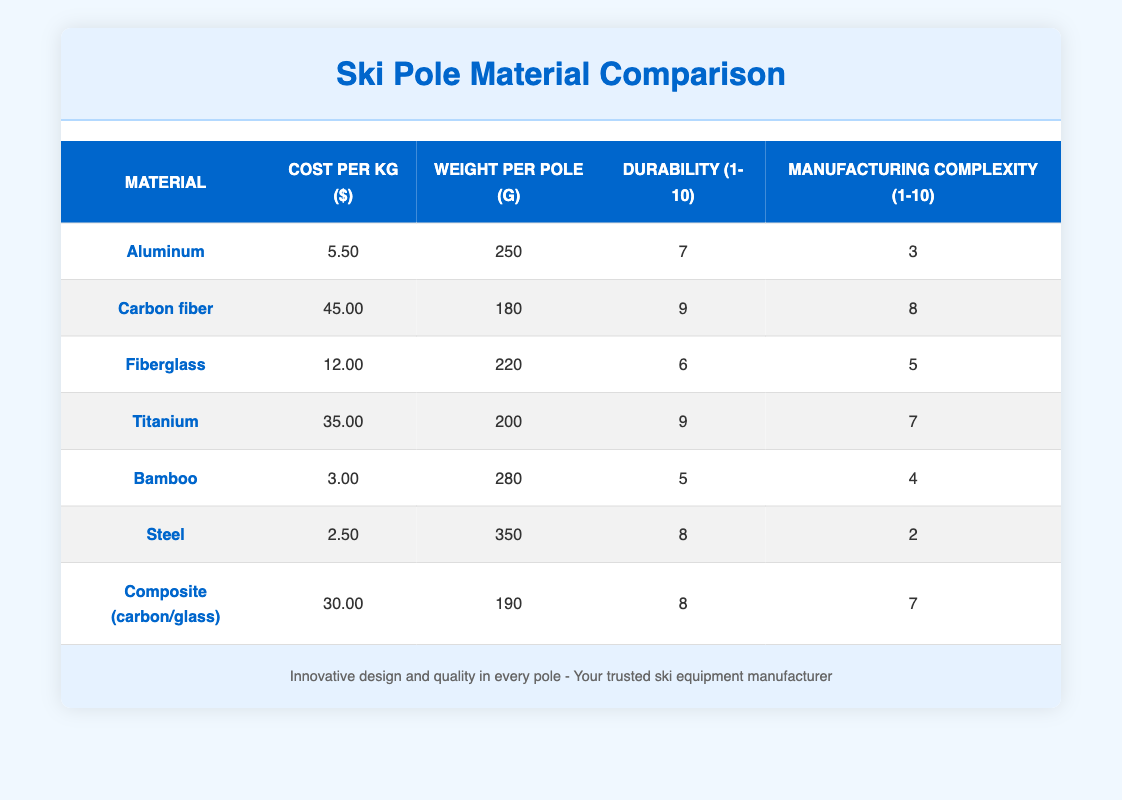What is the cost per kg of carbon fiber? The table states that the cost per kg of carbon fiber is listed directly under the "Cost per kg ($)" column in the corresponding row for carbon fiber. This value is 45.00.
Answer: 45.00 Which material has the highest durability rating? By looking at the "Durability (1-10)" column, the highest value present is 9, which appears in the rows for carbon fiber and titanium. Thus, these two materials have the highest durability rating.
Answer: Carbon fiber and titanium What is the average weight per pole of aluminum and fiberglass? The weight of aluminum is 250 g and fiberglass is 220 g. To find the average, we add the two weights: 250 + 220 = 470 g, then divide by 2 to get the average: 470 / 2 = 235 g.
Answer: 235 g Is bamboo more expensive than steel per kg? The cost per kg of bamboo is 3.00 and that of steel is 2.50. Since 3.00 is greater than 2.50, bamboo is indeed more expensive than steel.
Answer: Yes Which material has the lowest manufacturing complexity? From the "Manufacturing complexity (1-10)" column, the lowest value is 2, which corresponds to steel. Hence, steel has the lowest complexity in manufacturing among the listed materials.
Answer: Steel What is the total cost per kg of using composite (carbon/glass) and aluminum? The cost per kg of composite (carbon/glass) is 30.00 and aluminum is 5.50. To find the total cost, we add these values: 30.00 + 5.50 = 35.50.
Answer: 35.50 Which materials have a weight of less than 250 grams per pole? The materials with a weight less than 250 grams are carbon fiber (180 g), titanium (200 g), and bamboo (280 g, which does not qualify). Filtering the rows, we see only carbon fiber and titanium meet this criterion.
Answer: Carbon fiber and titanium What is the difference in durability between the strongest and the weakest material? The strongest material, carbon fiber and titanium, has a durability rating of 9, and the weakest, bamboo, has a rating of 5. The difference is calculated as follows: 9 - 5 = 4.
Answer: 4 